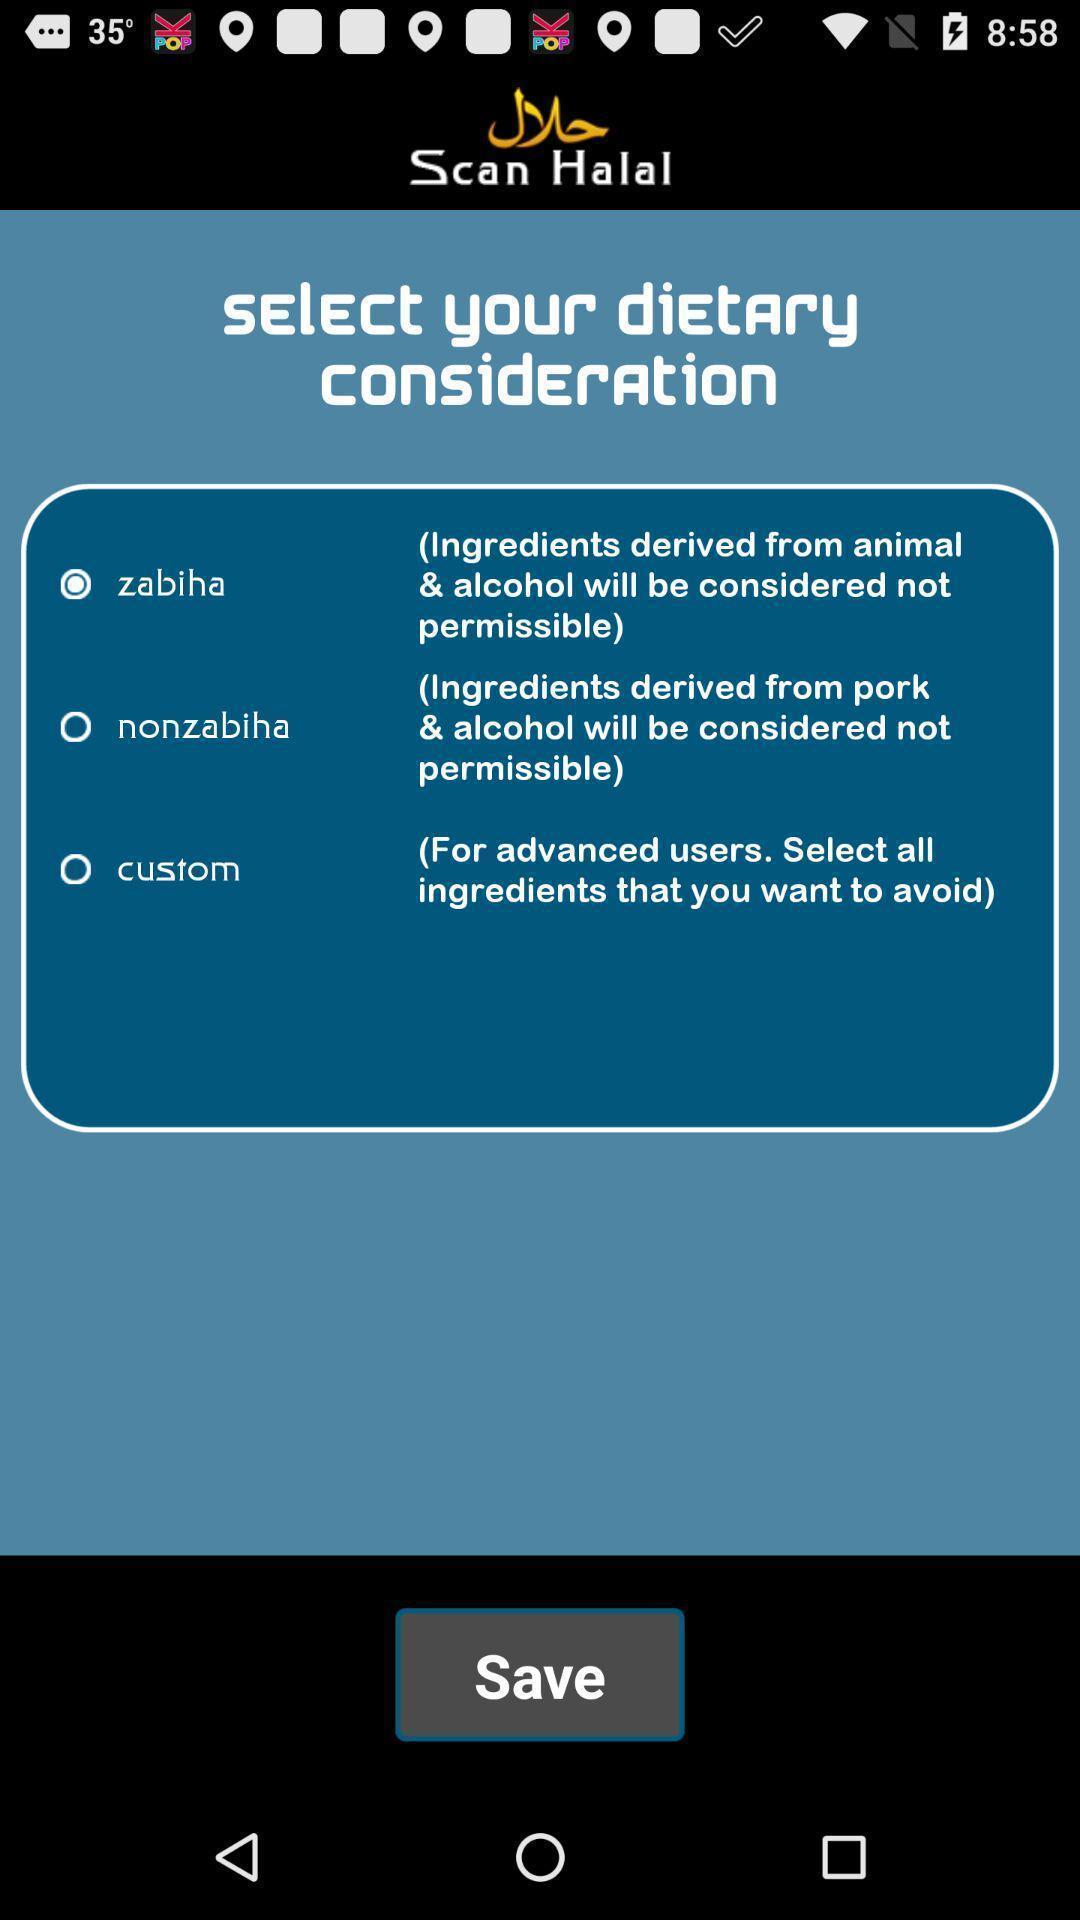Provide a description of this screenshot. Screen shows multiple options in a food application. 